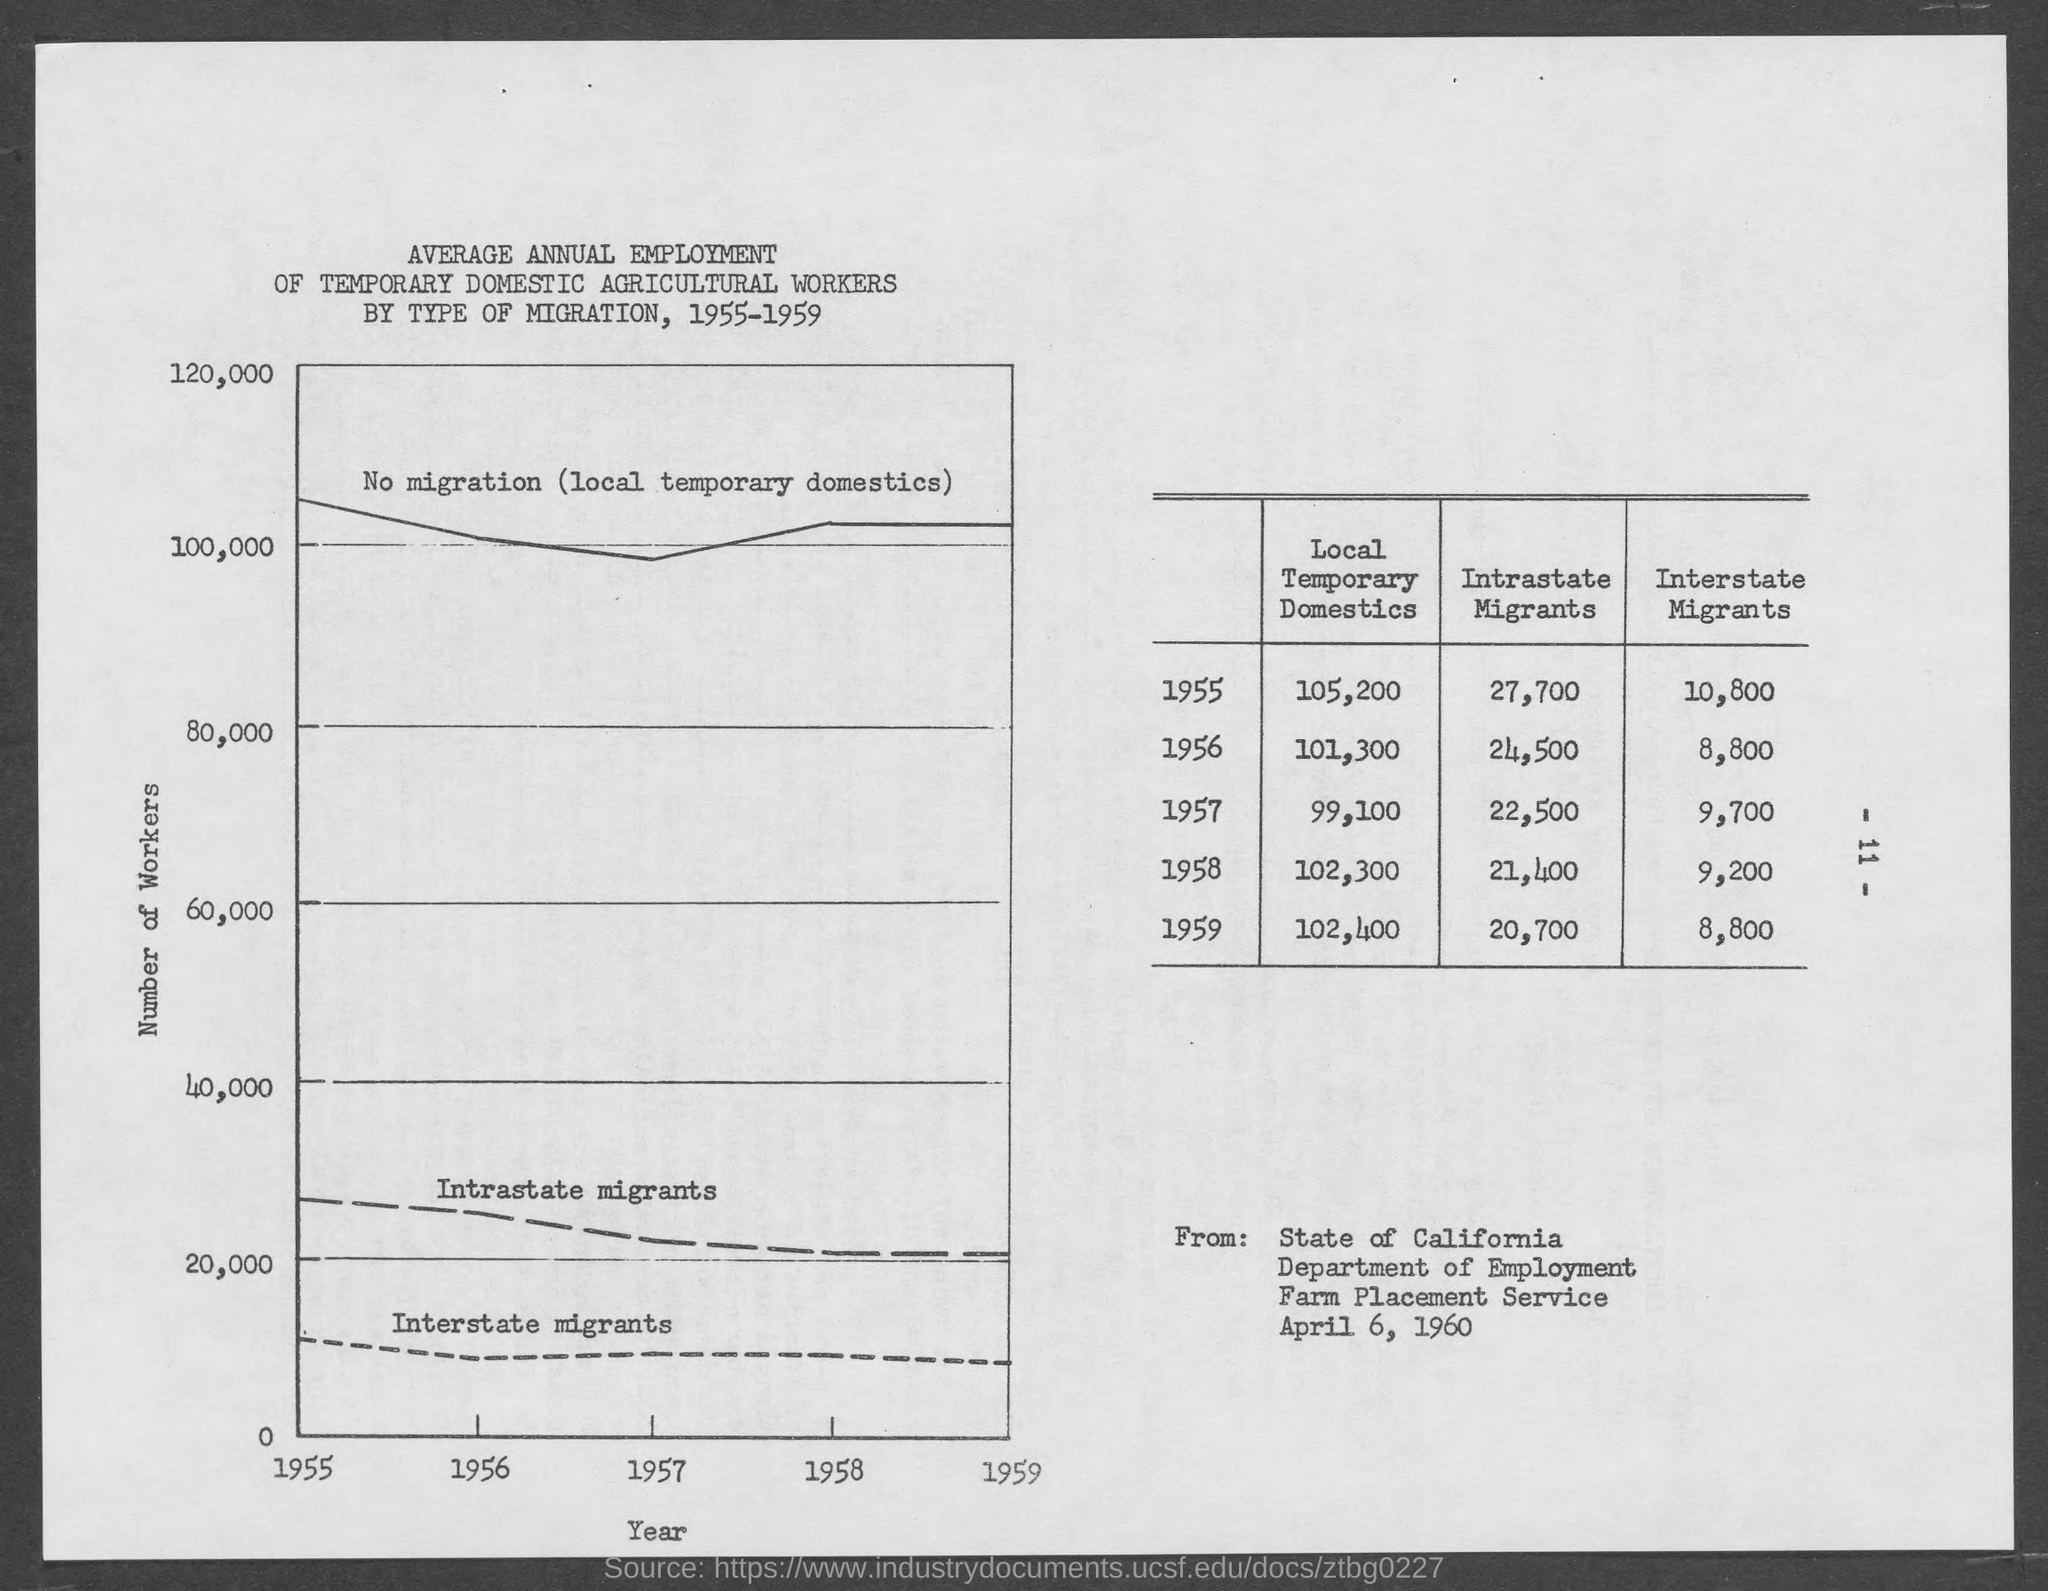Outline some significant characteristics in this image. What is depicted on the Y-axis? The number of workers. The year is displayed on the X-axis. 